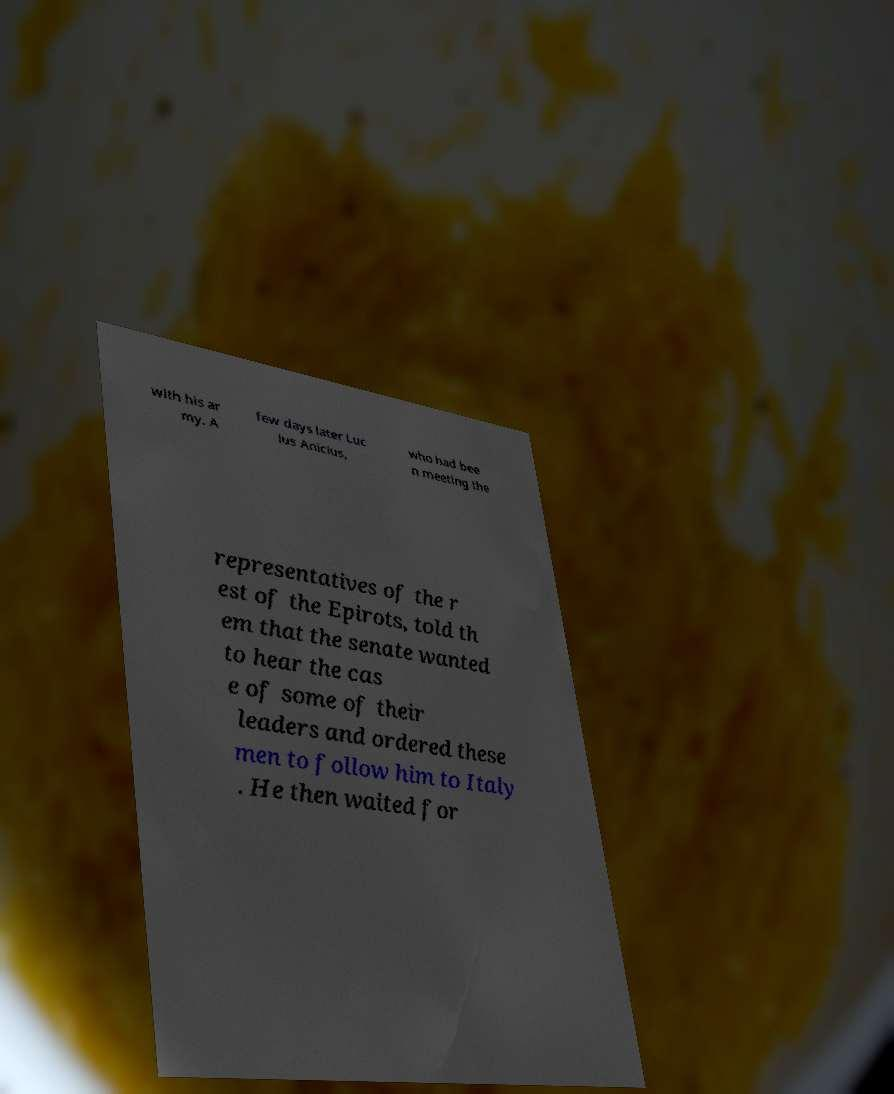Please identify and transcribe the text found in this image. with his ar my. A few days later Luc ius Anicius, who had bee n meeting the representatives of the r est of the Epirots, told th em that the senate wanted to hear the cas e of some of their leaders and ordered these men to follow him to Italy . He then waited for 